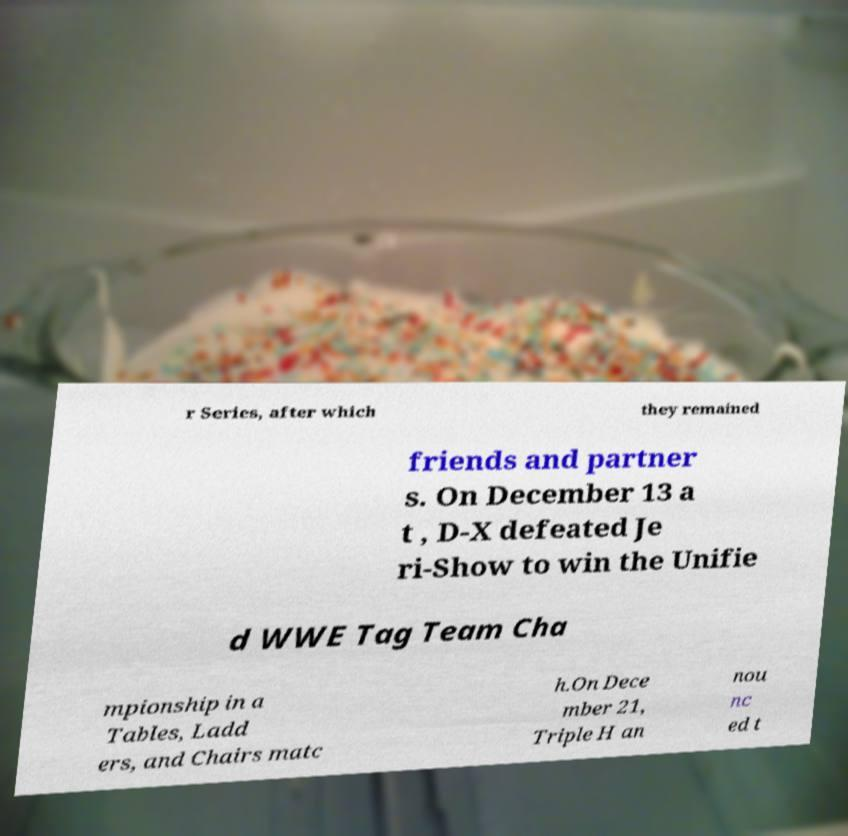What messages or text are displayed in this image? I need them in a readable, typed format. r Series, after which they remained friends and partner s. On December 13 a t , D-X defeated Je ri-Show to win the Unifie d WWE Tag Team Cha mpionship in a Tables, Ladd ers, and Chairs matc h.On Dece mber 21, Triple H an nou nc ed t 